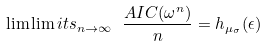<formula> <loc_0><loc_0><loc_500><loc_500>\lim \lim i t s _ { n \to \infty } \ \frac { A I C ( \omega ^ { n } ) } { n } = h _ { \mu _ { \sigma } } ( \epsilon )</formula> 